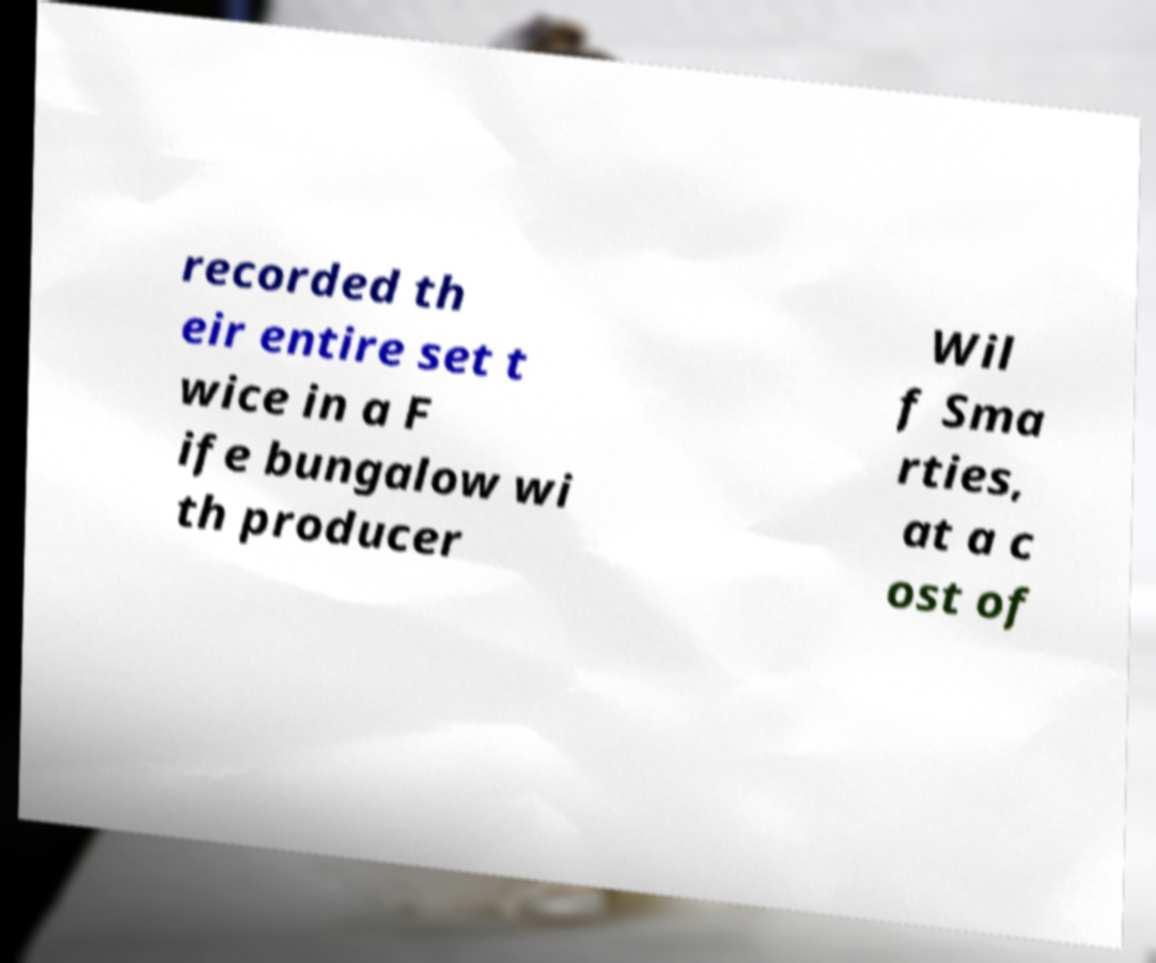I need the written content from this picture converted into text. Can you do that? recorded th eir entire set t wice in a F ife bungalow wi th producer Wil f Sma rties, at a c ost of 